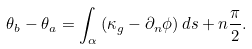Convert formula to latex. <formula><loc_0><loc_0><loc_500><loc_500>\theta _ { b } - \theta _ { a } = \int _ { \alpha } \left ( \kappa _ { g } - \partial _ { n } \phi \right ) d s + n \frac { \pi } { 2 } .</formula> 